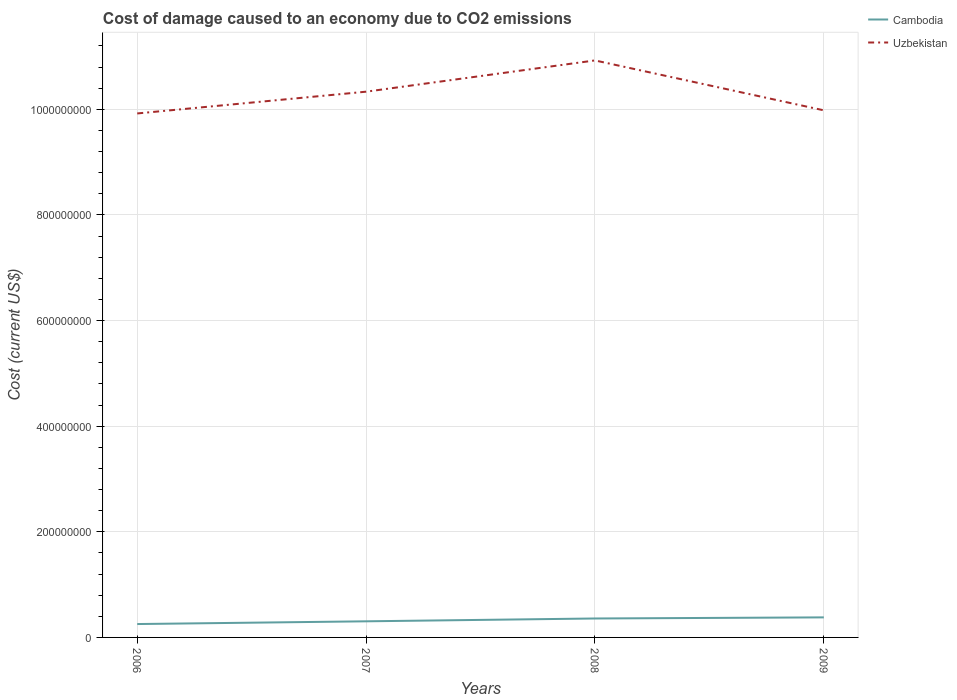Is the number of lines equal to the number of legend labels?
Offer a terse response. Yes. Across all years, what is the maximum cost of damage caused due to CO2 emissisons in Uzbekistan?
Offer a very short reply. 9.92e+08. What is the total cost of damage caused due to CO2 emissisons in Uzbekistan in the graph?
Make the answer very short. -5.92e+06. What is the difference between the highest and the second highest cost of damage caused due to CO2 emissisons in Cambodia?
Your answer should be compact. 1.26e+07. What is the difference between the highest and the lowest cost of damage caused due to CO2 emissisons in Cambodia?
Your answer should be compact. 2. How many years are there in the graph?
Keep it short and to the point. 4. What is the difference between two consecutive major ticks on the Y-axis?
Provide a succinct answer. 2.00e+08. Does the graph contain any zero values?
Keep it short and to the point. No. Does the graph contain grids?
Your answer should be very brief. Yes. How many legend labels are there?
Your response must be concise. 2. How are the legend labels stacked?
Provide a succinct answer. Vertical. What is the title of the graph?
Give a very brief answer. Cost of damage caused to an economy due to CO2 emissions. Does "High income: OECD" appear as one of the legend labels in the graph?
Offer a terse response. No. What is the label or title of the Y-axis?
Provide a short and direct response. Cost (current US$). What is the Cost (current US$) of Cambodia in 2006?
Your answer should be compact. 2.53e+07. What is the Cost (current US$) of Uzbekistan in 2006?
Offer a terse response. 9.92e+08. What is the Cost (current US$) in Cambodia in 2007?
Your answer should be very brief. 3.05e+07. What is the Cost (current US$) in Uzbekistan in 2007?
Offer a terse response. 1.03e+09. What is the Cost (current US$) in Cambodia in 2008?
Keep it short and to the point. 3.59e+07. What is the Cost (current US$) in Uzbekistan in 2008?
Your answer should be very brief. 1.09e+09. What is the Cost (current US$) in Cambodia in 2009?
Keep it short and to the point. 3.80e+07. What is the Cost (current US$) in Uzbekistan in 2009?
Offer a very short reply. 9.98e+08. Across all years, what is the maximum Cost (current US$) of Cambodia?
Give a very brief answer. 3.80e+07. Across all years, what is the maximum Cost (current US$) of Uzbekistan?
Keep it short and to the point. 1.09e+09. Across all years, what is the minimum Cost (current US$) in Cambodia?
Give a very brief answer. 2.53e+07. Across all years, what is the minimum Cost (current US$) of Uzbekistan?
Make the answer very short. 9.92e+08. What is the total Cost (current US$) in Cambodia in the graph?
Your response must be concise. 1.30e+08. What is the total Cost (current US$) of Uzbekistan in the graph?
Your response must be concise. 4.12e+09. What is the difference between the Cost (current US$) of Cambodia in 2006 and that in 2007?
Keep it short and to the point. -5.19e+06. What is the difference between the Cost (current US$) of Uzbekistan in 2006 and that in 2007?
Make the answer very short. -4.12e+07. What is the difference between the Cost (current US$) in Cambodia in 2006 and that in 2008?
Give a very brief answer. -1.05e+07. What is the difference between the Cost (current US$) of Uzbekistan in 2006 and that in 2008?
Provide a succinct answer. -1.00e+08. What is the difference between the Cost (current US$) in Cambodia in 2006 and that in 2009?
Ensure brevity in your answer.  -1.26e+07. What is the difference between the Cost (current US$) in Uzbekistan in 2006 and that in 2009?
Offer a very short reply. -5.92e+06. What is the difference between the Cost (current US$) in Cambodia in 2007 and that in 2008?
Provide a succinct answer. -5.36e+06. What is the difference between the Cost (current US$) of Uzbekistan in 2007 and that in 2008?
Your answer should be compact. -5.92e+07. What is the difference between the Cost (current US$) in Cambodia in 2007 and that in 2009?
Offer a very short reply. -7.46e+06. What is the difference between the Cost (current US$) of Uzbekistan in 2007 and that in 2009?
Your answer should be very brief. 3.53e+07. What is the difference between the Cost (current US$) of Cambodia in 2008 and that in 2009?
Offer a very short reply. -2.10e+06. What is the difference between the Cost (current US$) of Uzbekistan in 2008 and that in 2009?
Make the answer very short. 9.45e+07. What is the difference between the Cost (current US$) in Cambodia in 2006 and the Cost (current US$) in Uzbekistan in 2007?
Make the answer very short. -1.01e+09. What is the difference between the Cost (current US$) of Cambodia in 2006 and the Cost (current US$) of Uzbekistan in 2008?
Keep it short and to the point. -1.07e+09. What is the difference between the Cost (current US$) of Cambodia in 2006 and the Cost (current US$) of Uzbekistan in 2009?
Offer a very short reply. -9.73e+08. What is the difference between the Cost (current US$) in Cambodia in 2007 and the Cost (current US$) in Uzbekistan in 2008?
Your answer should be compact. -1.06e+09. What is the difference between the Cost (current US$) of Cambodia in 2007 and the Cost (current US$) of Uzbekistan in 2009?
Give a very brief answer. -9.68e+08. What is the difference between the Cost (current US$) of Cambodia in 2008 and the Cost (current US$) of Uzbekistan in 2009?
Offer a terse response. -9.62e+08. What is the average Cost (current US$) of Cambodia per year?
Provide a succinct answer. 3.24e+07. What is the average Cost (current US$) in Uzbekistan per year?
Provide a short and direct response. 1.03e+09. In the year 2006, what is the difference between the Cost (current US$) of Cambodia and Cost (current US$) of Uzbekistan?
Your answer should be very brief. -9.67e+08. In the year 2007, what is the difference between the Cost (current US$) of Cambodia and Cost (current US$) of Uzbekistan?
Your response must be concise. -1.00e+09. In the year 2008, what is the difference between the Cost (current US$) of Cambodia and Cost (current US$) of Uzbekistan?
Keep it short and to the point. -1.06e+09. In the year 2009, what is the difference between the Cost (current US$) in Cambodia and Cost (current US$) in Uzbekistan?
Provide a short and direct response. -9.60e+08. What is the ratio of the Cost (current US$) in Cambodia in 2006 to that in 2007?
Keep it short and to the point. 0.83. What is the ratio of the Cost (current US$) in Uzbekistan in 2006 to that in 2007?
Your answer should be very brief. 0.96. What is the ratio of the Cost (current US$) of Cambodia in 2006 to that in 2008?
Ensure brevity in your answer.  0.71. What is the ratio of the Cost (current US$) of Uzbekistan in 2006 to that in 2008?
Offer a very short reply. 0.91. What is the ratio of the Cost (current US$) of Cambodia in 2006 to that in 2009?
Offer a very short reply. 0.67. What is the ratio of the Cost (current US$) of Cambodia in 2007 to that in 2008?
Give a very brief answer. 0.85. What is the ratio of the Cost (current US$) of Uzbekistan in 2007 to that in 2008?
Give a very brief answer. 0.95. What is the ratio of the Cost (current US$) in Cambodia in 2007 to that in 2009?
Ensure brevity in your answer.  0.8. What is the ratio of the Cost (current US$) of Uzbekistan in 2007 to that in 2009?
Provide a short and direct response. 1.04. What is the ratio of the Cost (current US$) in Cambodia in 2008 to that in 2009?
Provide a succinct answer. 0.94. What is the ratio of the Cost (current US$) in Uzbekistan in 2008 to that in 2009?
Keep it short and to the point. 1.09. What is the difference between the highest and the second highest Cost (current US$) in Cambodia?
Your answer should be very brief. 2.10e+06. What is the difference between the highest and the second highest Cost (current US$) of Uzbekistan?
Your response must be concise. 5.92e+07. What is the difference between the highest and the lowest Cost (current US$) of Cambodia?
Give a very brief answer. 1.26e+07. What is the difference between the highest and the lowest Cost (current US$) in Uzbekistan?
Give a very brief answer. 1.00e+08. 